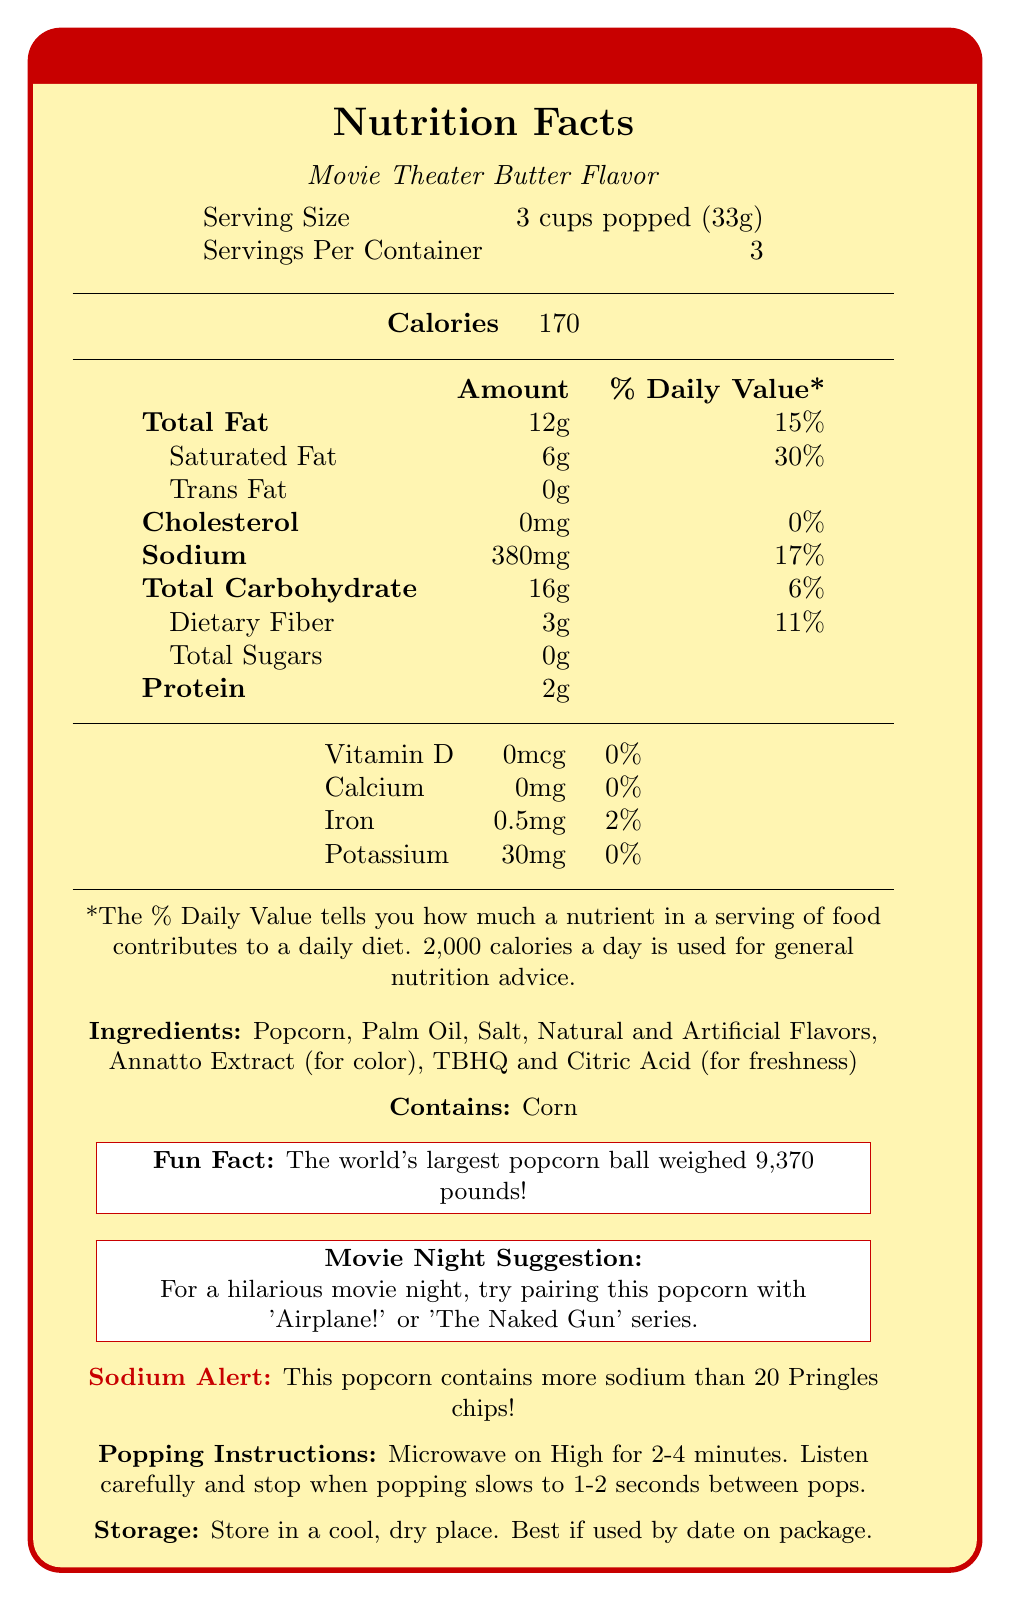How many grams of total fat are in one serving of Pop-A-Lot Microwave Popcorn? The nutrition facts label specifies that each serving contains 12 grams of total fat.
Answer: 12g What is the serving size for Pop-A-Lot Microwave Popcorn? The document states that one serving size is 3 cups popped, which weighs 33 grams.
Answer: 3 cups popped (33g) How much sodium does one serving of this popcorn contain? According to the nutrition facts, there are 380 milligrams of sodium in one serving.
Answer: 380mg What percentage of the daily value for saturated fat does one serving contain? The label shows that the saturated fat content is 6 grams, which is 30% of the daily value.
Answer: 30% How much dietary fiber is there in one serving of Pop-A-Lot Microwave Popcorn? The document notes that each serving contains 3 grams of dietary fiber.
Answer: 3g Which of the following ingredients are included in the Pop-A-Lot Microwave Popcorn? (Select all that apply)  
1. Butter  
2. Palm Oil  
3. Natural Flavors  
4. Salt The ingredients list includes "Palm Oil" and "Salt" but does not mention "Butter" or "Natural Flavors."
Answer: 2. Palm Oil, 4. Salt What is the daily percentage value of calcium in one serving of this popcorn?  
A. 5%  
B. 10%  
C. 0%  
D. 20% The label indicates that the calcium content is 0 milligrams, which contributes 0% of the daily value.
Answer: C. 0% Does Pop-A-Lot Microwave Popcorn contain any trans fat? The nutrition facts label indicates that the trans fat content is 0 grams.
Answer: No Can the document tell you how much sugar is in one serving? The nutrition facts indicate that one serving contains 0 grams of total sugars.
Answer: Yes What is a fun fact mentioned about popcorn in the document? The "Fun Fact" section of the document highlights this information about popcorn.
Answer: The world's largest popcorn ball weighed 9,370 pounds! Does this popcorn contain any common allergens? The allergen information states that it contains corn.
Answer: Yes How many servings are there per container? The document specifies that there are 3 servings per container.
Answer: 3 servings Which nutrient in the popcorn has the highest percentage of daily value? The label shows that saturated fat has the highest daily value percentage at 30%.
Answer: Saturated Fat What vitamins or minerals are listed on the label, and what are their daily values? The label lists Vitamin D, Calcium, Iron, and Potassium with corresponding daily values mentioned.
Answer: Vitamin D 0%, Calcium 0%, Iron 2%, Potassium 0% How does the sodium content in one serving of this popcorn compare to 20 Pringles chips? The "Sodium Alert" section of the document specifically points out that one serving of this popcorn has more sodium than 20 Pringles chips.
Answer: This popcorn contains more sodium than 20 Pringles chips. What is the brand name of the popcorn? The title and opening section of the document states the brand name clearly.
Answer: Pop-A-Lot Microwave Popcorn What is the suggested movie night pairing mentioned in the document? The "Movie Night Suggestion" section suggests pairing this popcorn with these comedy movies.
Answer: 'Airplane!' or 'The Naked Gun' series What is the document's guidance on storing the popcorn? The "Storage" section provides this information.
Answer: Store in a cool, dry place. Best if used by date on package. What is the fun fact specific to this document? The "Fun Fact" section provides this information specifically related to popcorn.
Answer: The world's largest popcorn ball weighed 9,370 pounds! How long should you microwave the popcorn for optimal results? The "Popping Instructions" section provides this detailed information.
Answer: 2-4 minutes. Listen carefully and stop when popping slows to 1-2 seconds between pops. Does the document specify the amount of cholesterol per serving? The label indicates that each serving contains 0 milligrams of cholesterol.
Answer: Yes, it states 0mg. What flavors are mentioned in the ingredients? The ingredients list mentions "Natural and Artificial Flavors."
Answer: Natural and Artificial Flavors How much protein is in one serving of this popcorn? The nutrition facts label states that each serving contains 2 grams of protein.
Answer: 2g Approximately how many calories would one consume if they ate the whole container? There are 170 calories per serving, and the container has 3 servings, equating to 170 x 3 = 510 calories.
Answer: 510 calories What is the total carbohydrate content per serving? The nutrition facts indicate there are 16 grams of total carbohydrates per serving.
Answer: 16g Is the information on the safety of artificial flavoring provided in the document? The document does not provide any information on the safety of artificial flavoring.
Answer: Cannot be determined 